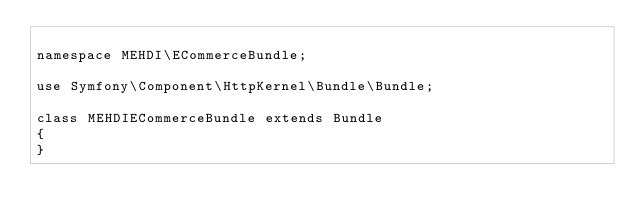<code> <loc_0><loc_0><loc_500><loc_500><_PHP_>
namespace MEHDI\ECommerceBundle;

use Symfony\Component\HttpKernel\Bundle\Bundle;

class MEHDIECommerceBundle extends Bundle
{
}
</code> 